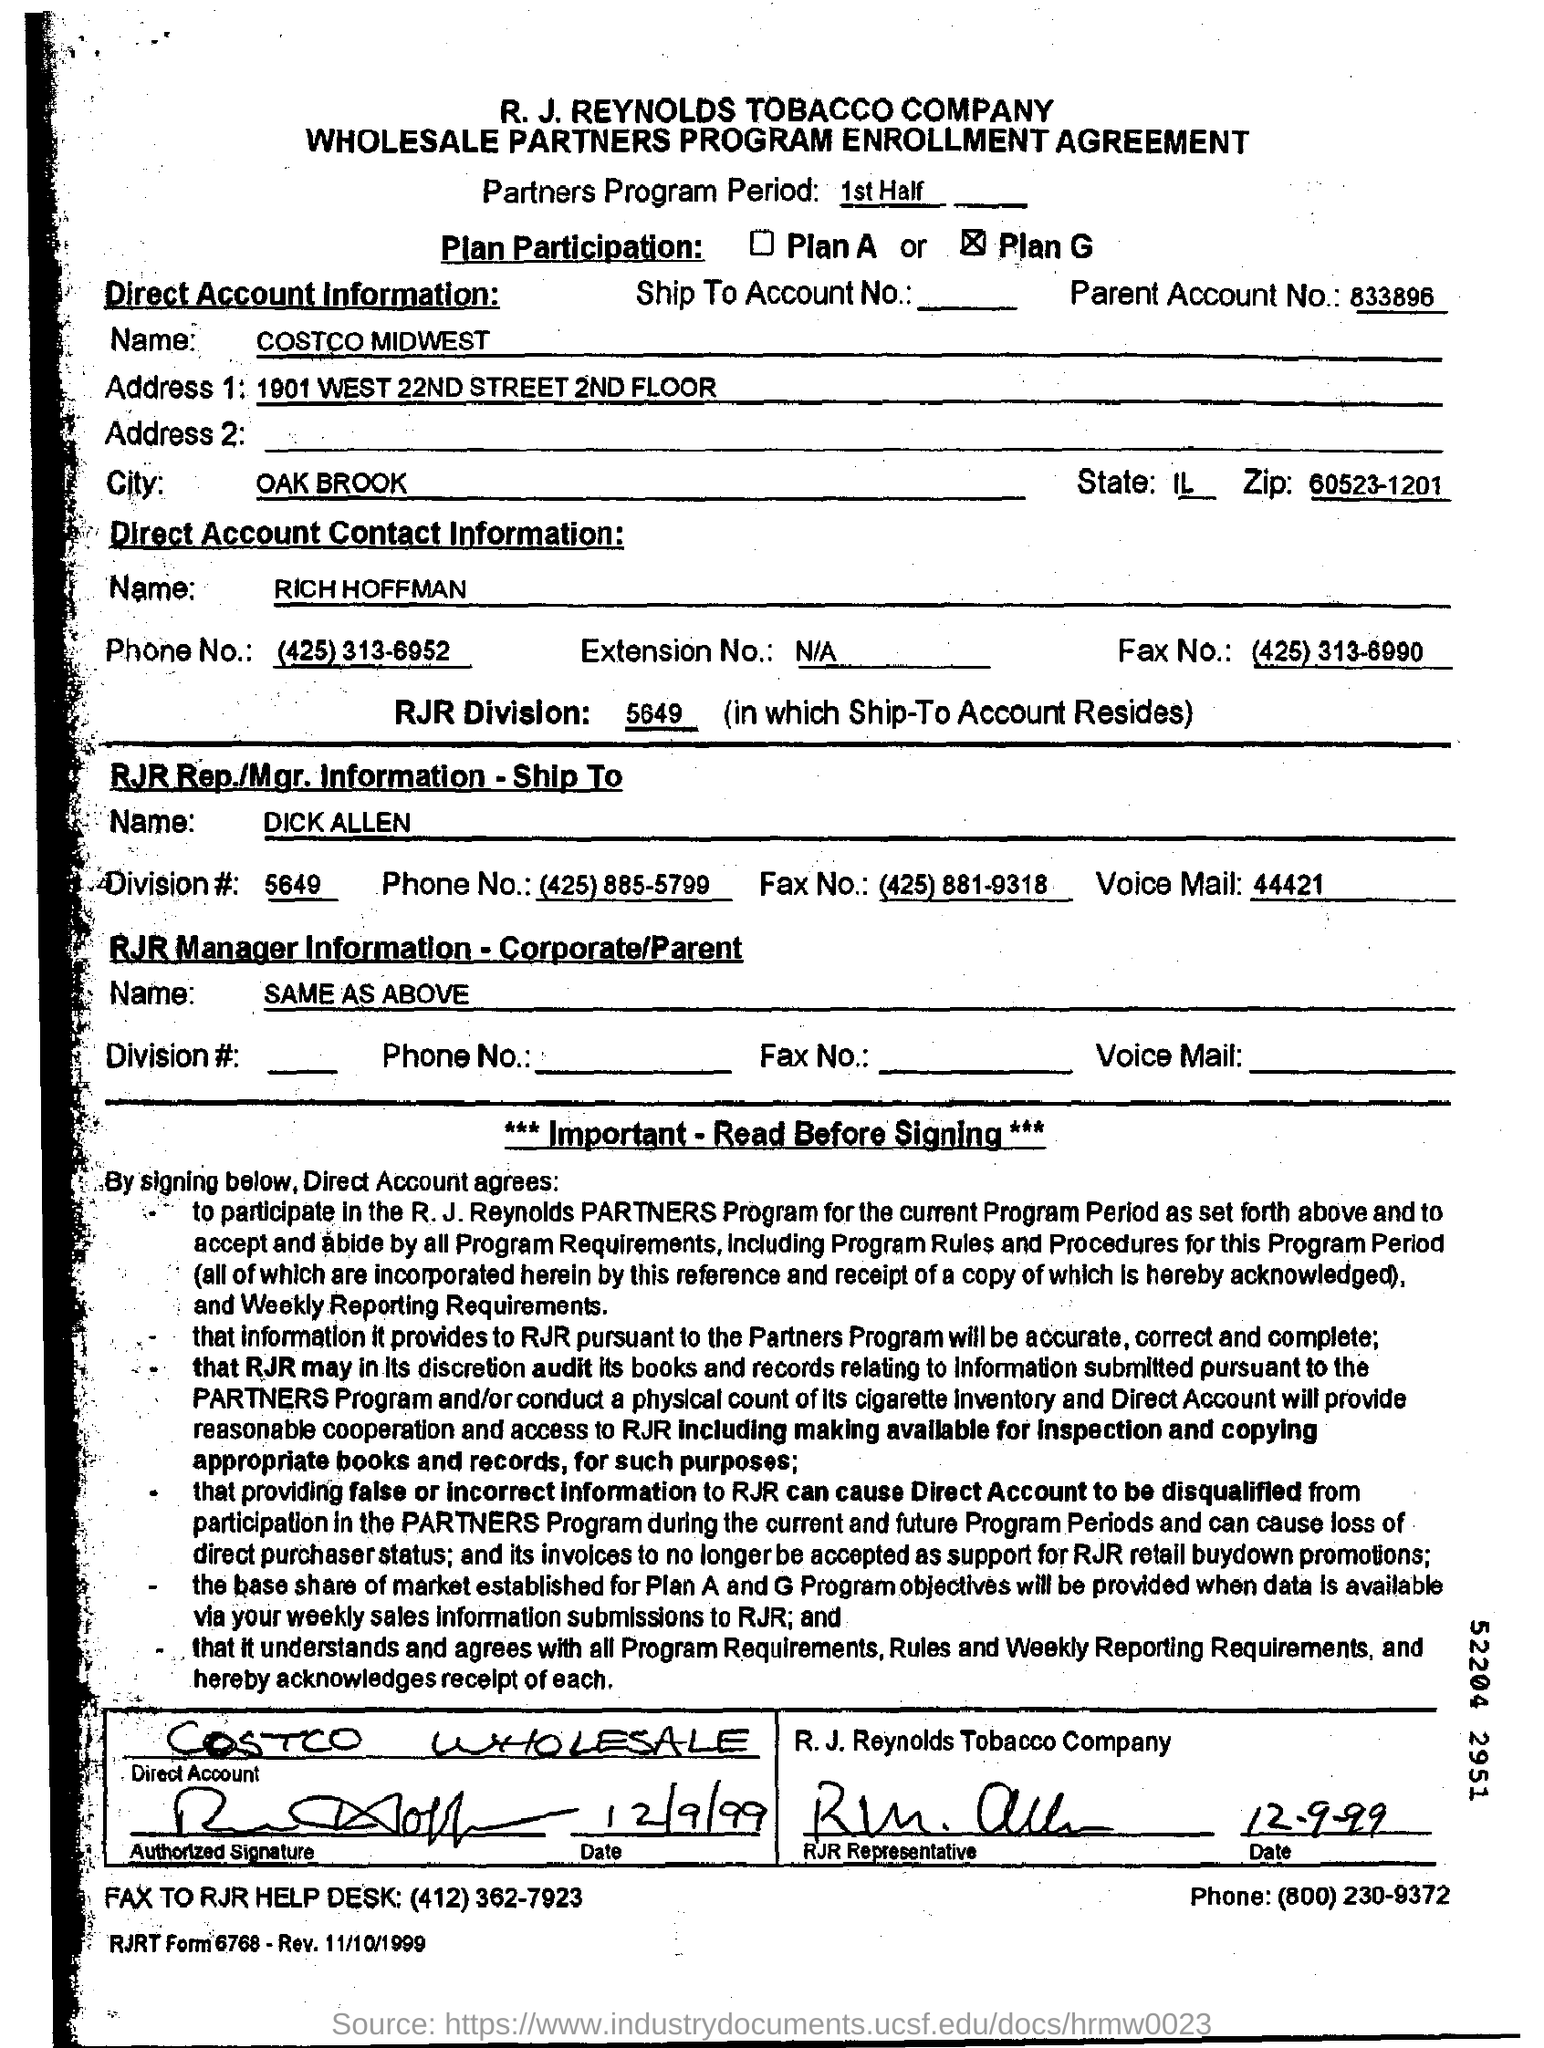Point out several critical features in this image. Can you please provide the account number of the parent? The name of RJR Rep./Mgr. is Dick Allen. The name given in Direct Account Information is "COSTCO MIDWEST. 